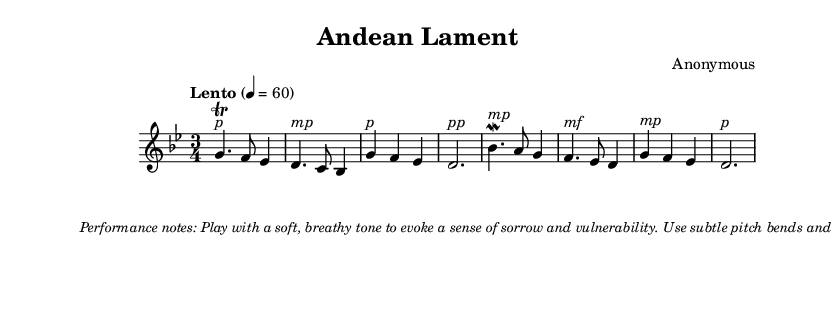What is the key signature of this music? The key signature indicates the notes that are sharp or flat in the piece. Here, the key signature is G minor, which has two flats (B♭ and E♭).
Answer: G minor What is the time signature of the piece? The time signature shows how many beats are in each measure. In this score, the time signature is 3/4, which means there are three beats per measure, and the quarter note gets one beat.
Answer: 3/4 What is the tempo marking given in the score? The tempo is indicated at the beginning of the piece, showing how fast or slow it should be played. Here, it is marked as "Lento," which suggests a slow tempo.
Answer: Lento How many total measures are there in this music? To find the total number of measures, one can count the measures indicated by the layout. Here, there are a total of eight measures visible in the score.
Answer: 8 What type of musical dynamics are used in the score? Dynamics indicate the volume of the music. In this piece, terms such as "p" (piano), "mp" (mezzo-piano), and "mf" (mezzo-forte) show varying dynamics, suggesting soft and moderate volume playing.
Answer: piano, mezzo-piano, mezzo-forte What is the primary playing technique suggested in the performance notes? The performance notes often provide guidance on how to execute the music expressively. In this score, it suggests playing with a soft, breathy tone, indicating a specific emotional delivery.
Answer: soft, breathy tone What is the emotional expression emphasized in this piece? Emotional expression in music can be determined by dynamics, tempo, and suggested performance techniques. This score emphasizes sorrow and vulnerability through specific playing techniques and tonal qualities.
Answer: sorrow and vulnerability 